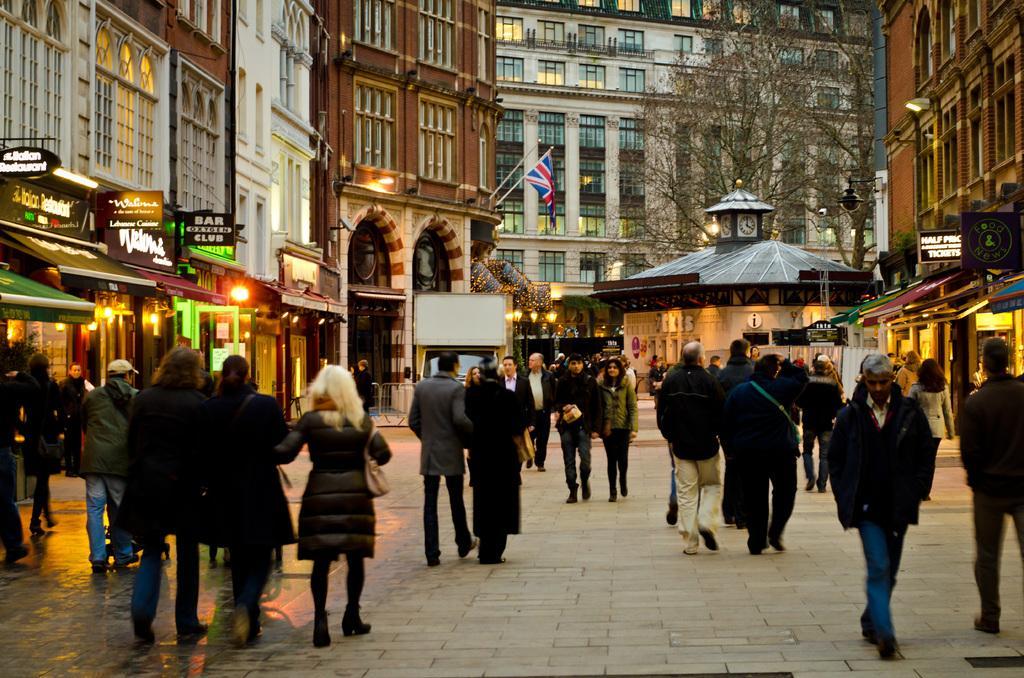Can you describe this image briefly? In this image, we can see a group of people. Few people are walking and standing on the platform. Background we can see so many buildings with walls, windows. Here we can see few shops, banners, hoardings, lights, clocks, flag, trees, boards. 